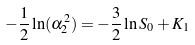Convert formula to latex. <formula><loc_0><loc_0><loc_500><loc_500>- \frac { 1 } { 2 } \ln ( \alpha _ { 2 } ^ { 2 } ) = - \frac { 3 } { 2 } \ln S _ { 0 } + K _ { 1 }</formula> 